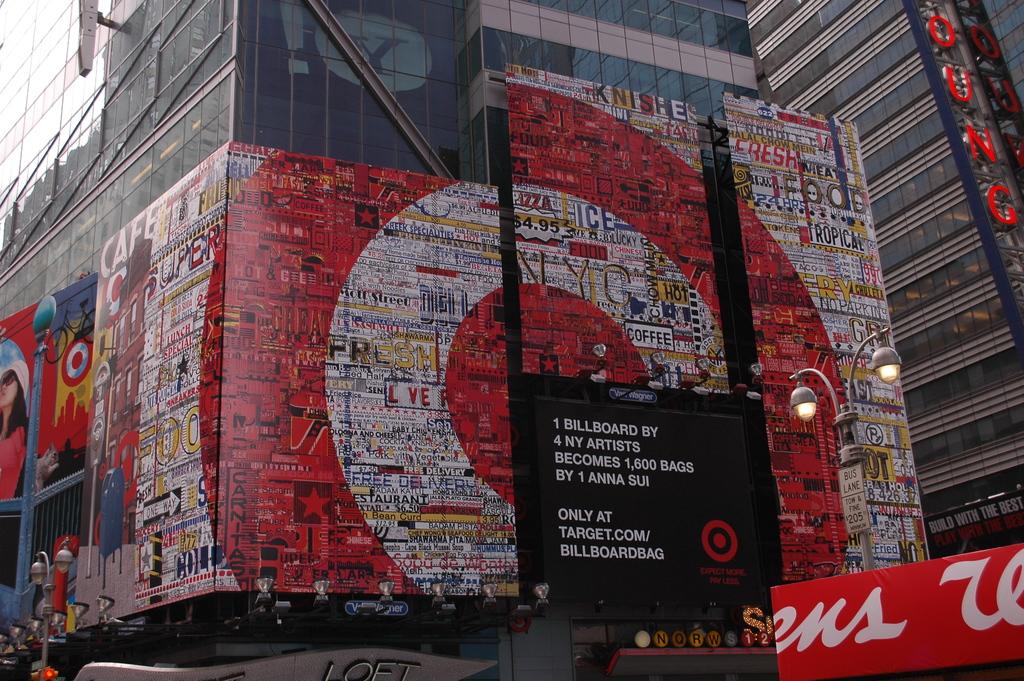What is the company featured on the screen?
Keep it short and to the point. Target. Is that large billboard for the company target?
Your answer should be compact. Yes. 